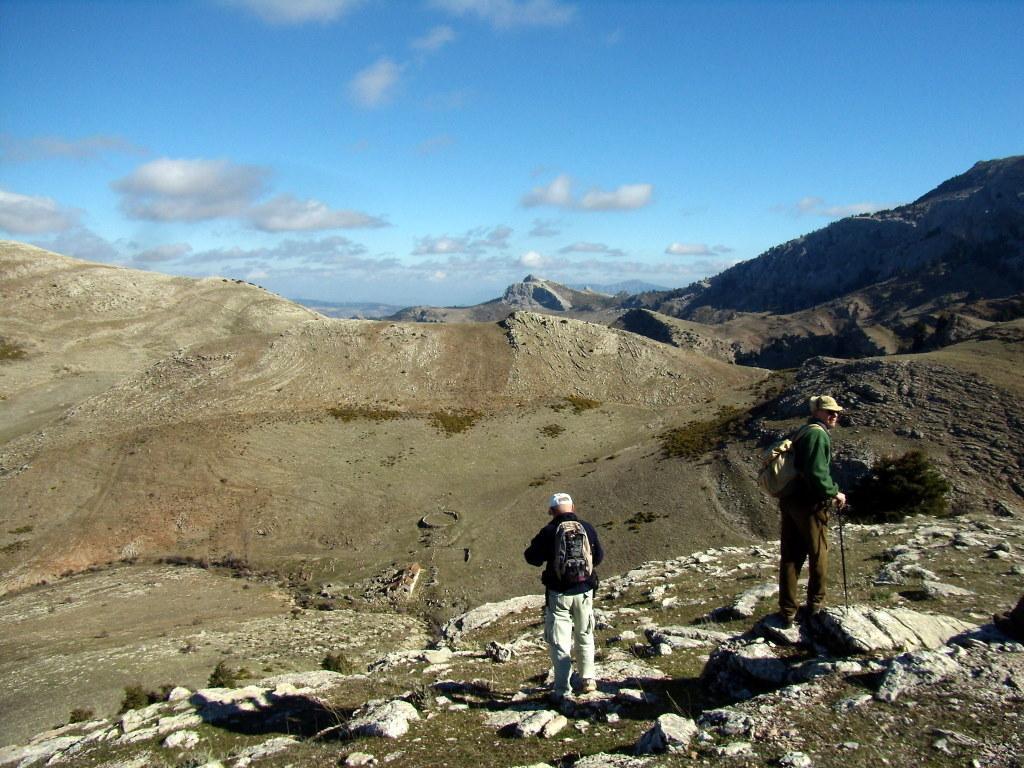Please provide a concise description of this image. In this image, there are a few hills. We can see some people carrying bags. We can see the ground and some stones. We can also see the sky with clouds. 